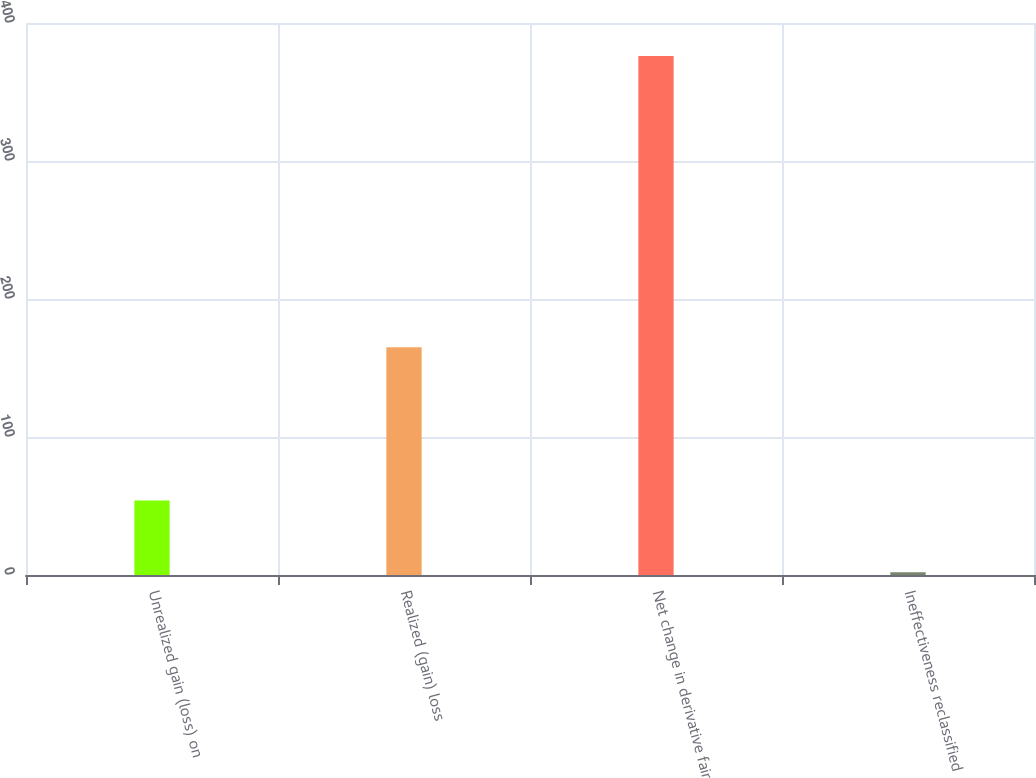Convert chart to OTSL. <chart><loc_0><loc_0><loc_500><loc_500><bar_chart><fcel>Unrealized gain (loss) on<fcel>Realized (gain) loss<fcel>Net change in derivative fair<fcel>Ineffectiveness reclassified<nl><fcel>54<fcel>165<fcel>376<fcel>2<nl></chart> 